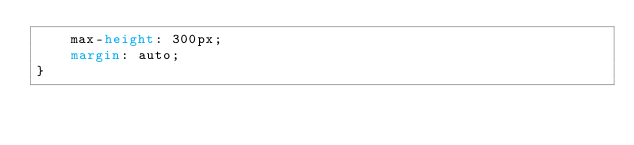Convert code to text. <code><loc_0><loc_0><loc_500><loc_500><_CSS_>    max-height: 300px;
    margin: auto;
}
</code> 